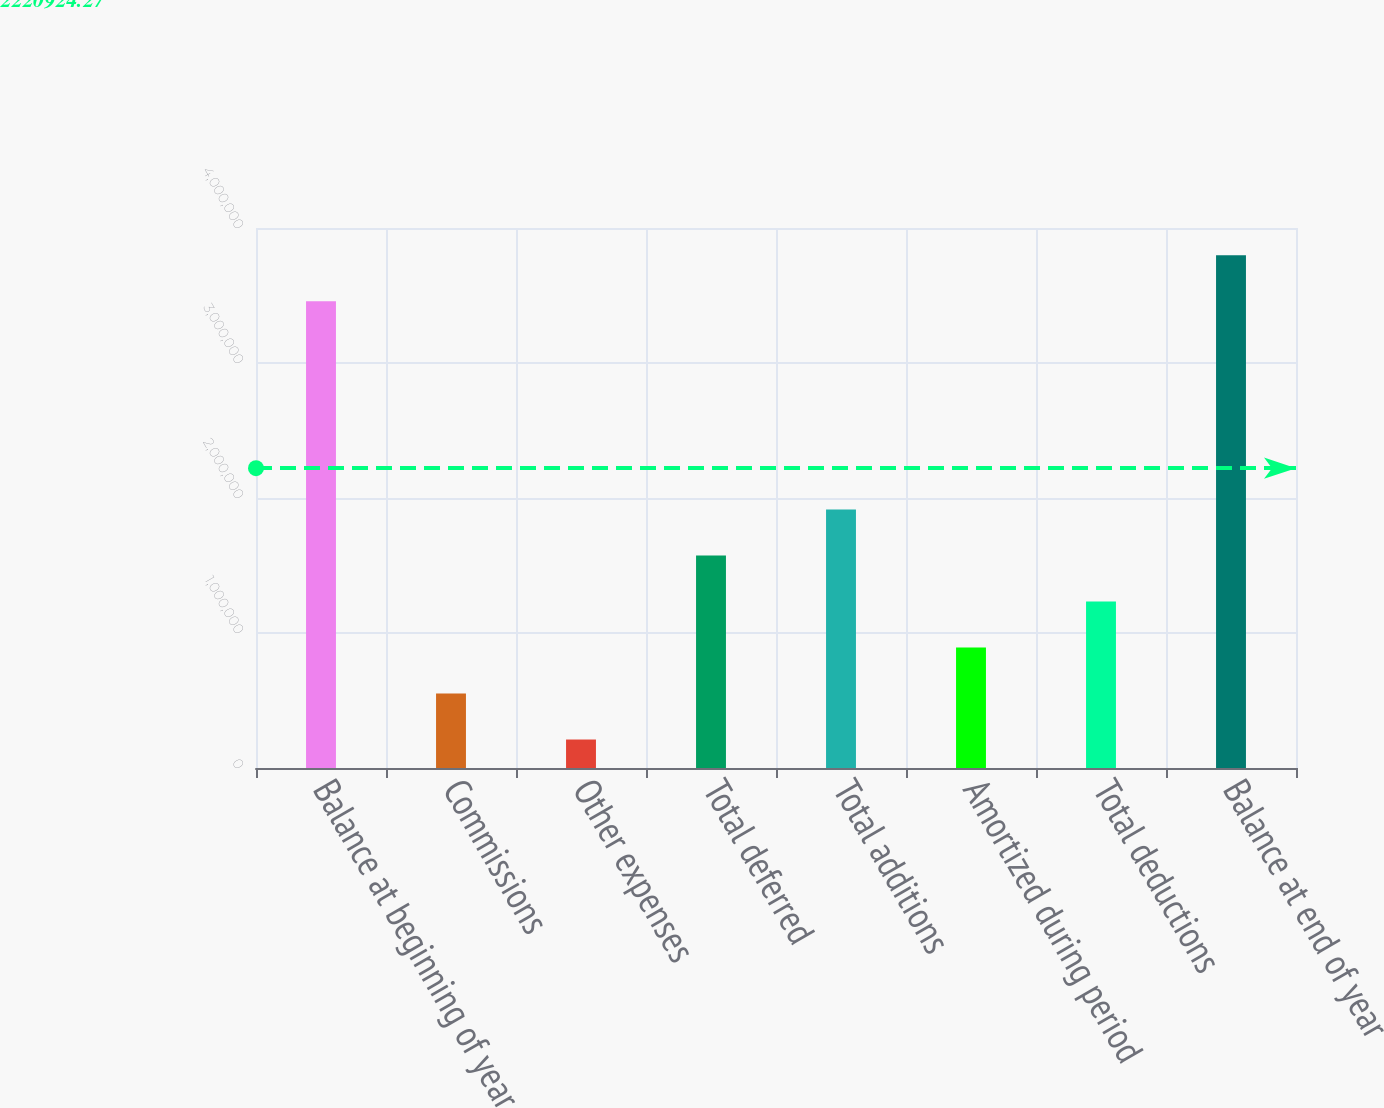Convert chart to OTSL. <chart><loc_0><loc_0><loc_500><loc_500><bar_chart><fcel>Balance at beginning of year<fcel>Commissions<fcel>Other expenses<fcel>Total deferred<fcel>Total additions<fcel>Amortized during period<fcel>Total deductions<fcel>Balance at end of year<nl><fcel>3.4574e+06<fcel>551627<fcel>211015<fcel>1.57346e+06<fcel>1.91408e+06<fcel>892239<fcel>1.23285e+06<fcel>3.79801e+06<nl></chart> 